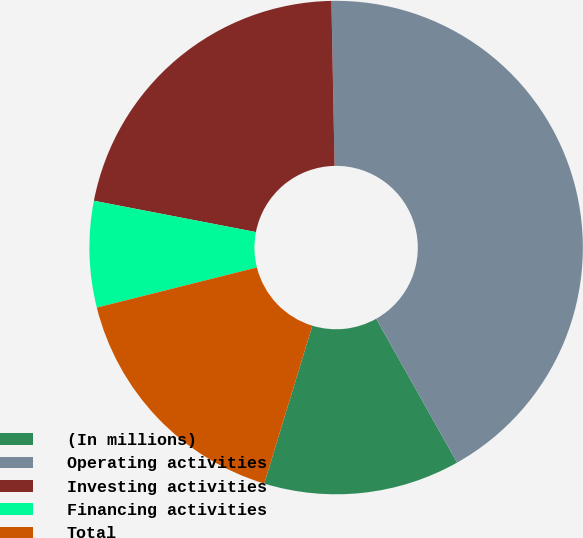Convert chart. <chart><loc_0><loc_0><loc_500><loc_500><pie_chart><fcel>(In millions)<fcel>Operating activities<fcel>Investing activities<fcel>Financing activities<fcel>Total<nl><fcel>12.86%<fcel>42.15%<fcel>21.66%<fcel>6.95%<fcel>16.38%<nl></chart> 